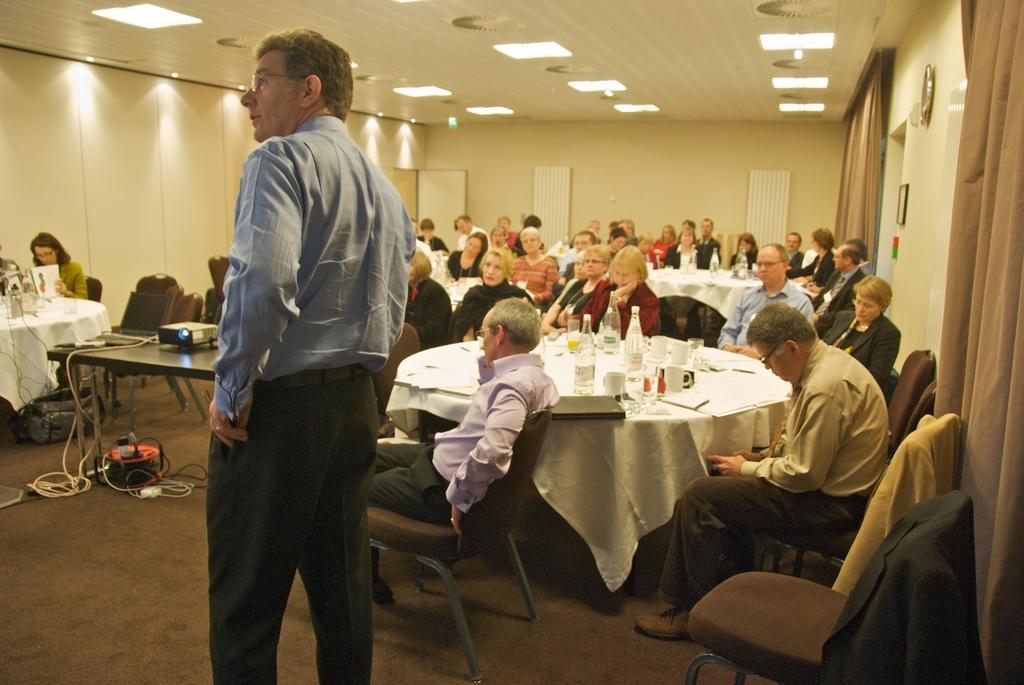Could you give a brief overview of what you see in this image? In this image there are group of people who are sitting on a chair and some tables are there, and on the table there are some bottles and cups and some books are there and on the right side there is one table. On that table there is one projector and some wires are there on the top there is ceiling and some lights are there and in the center there is one person who is standing. On the right side there is a wall and two curtains are there. 